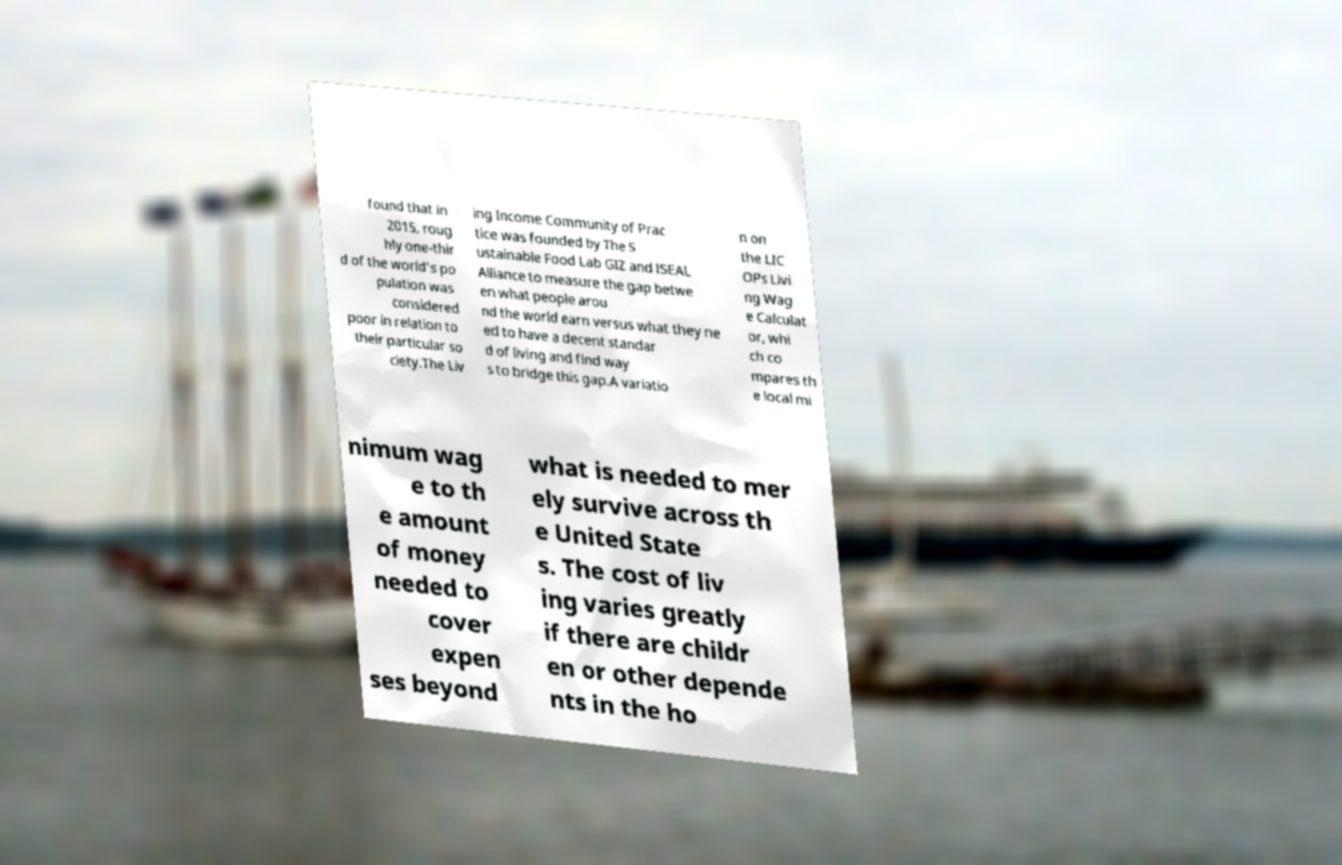Please identify and transcribe the text found in this image. found that in 2015, roug hly one-thir d of the world's po pulation was considered poor in relation to their particular so ciety.The Liv ing Income Community of Prac tice was founded by The S ustainable Food Lab GIZ and ISEAL Alliance to measure the gap betwe en what people arou nd the world earn versus what they ne ed to have a decent standar d of living and find way s to bridge this gap.A variatio n on the LIC OPs Livi ng Wag e Calculat or, whi ch co mpares th e local mi nimum wag e to th e amount of money needed to cover expen ses beyond what is needed to mer ely survive across th e United State s. The cost of liv ing varies greatly if there are childr en or other depende nts in the ho 